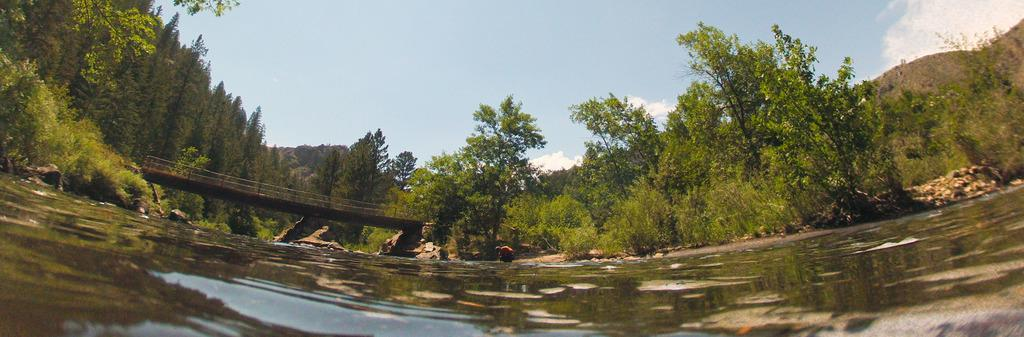What type of water body is visible in the image? There is a water body in the image, but the specific type is not mentioned. What structure can be seen crossing the water body? There is a bridge in the image. What can be seen in the background of the image? There are trees in the background of the image. How would you describe the sky in the image? The sky is blue with clouds. Can you see a turkey walking on the bridge in the image? There is no turkey present in the image, and therefore no such activity can be observed. What is the magical effect of the clouds in the image? There is no mention of magic or any magical effects in the image; the clouds are simply part of the sky. 